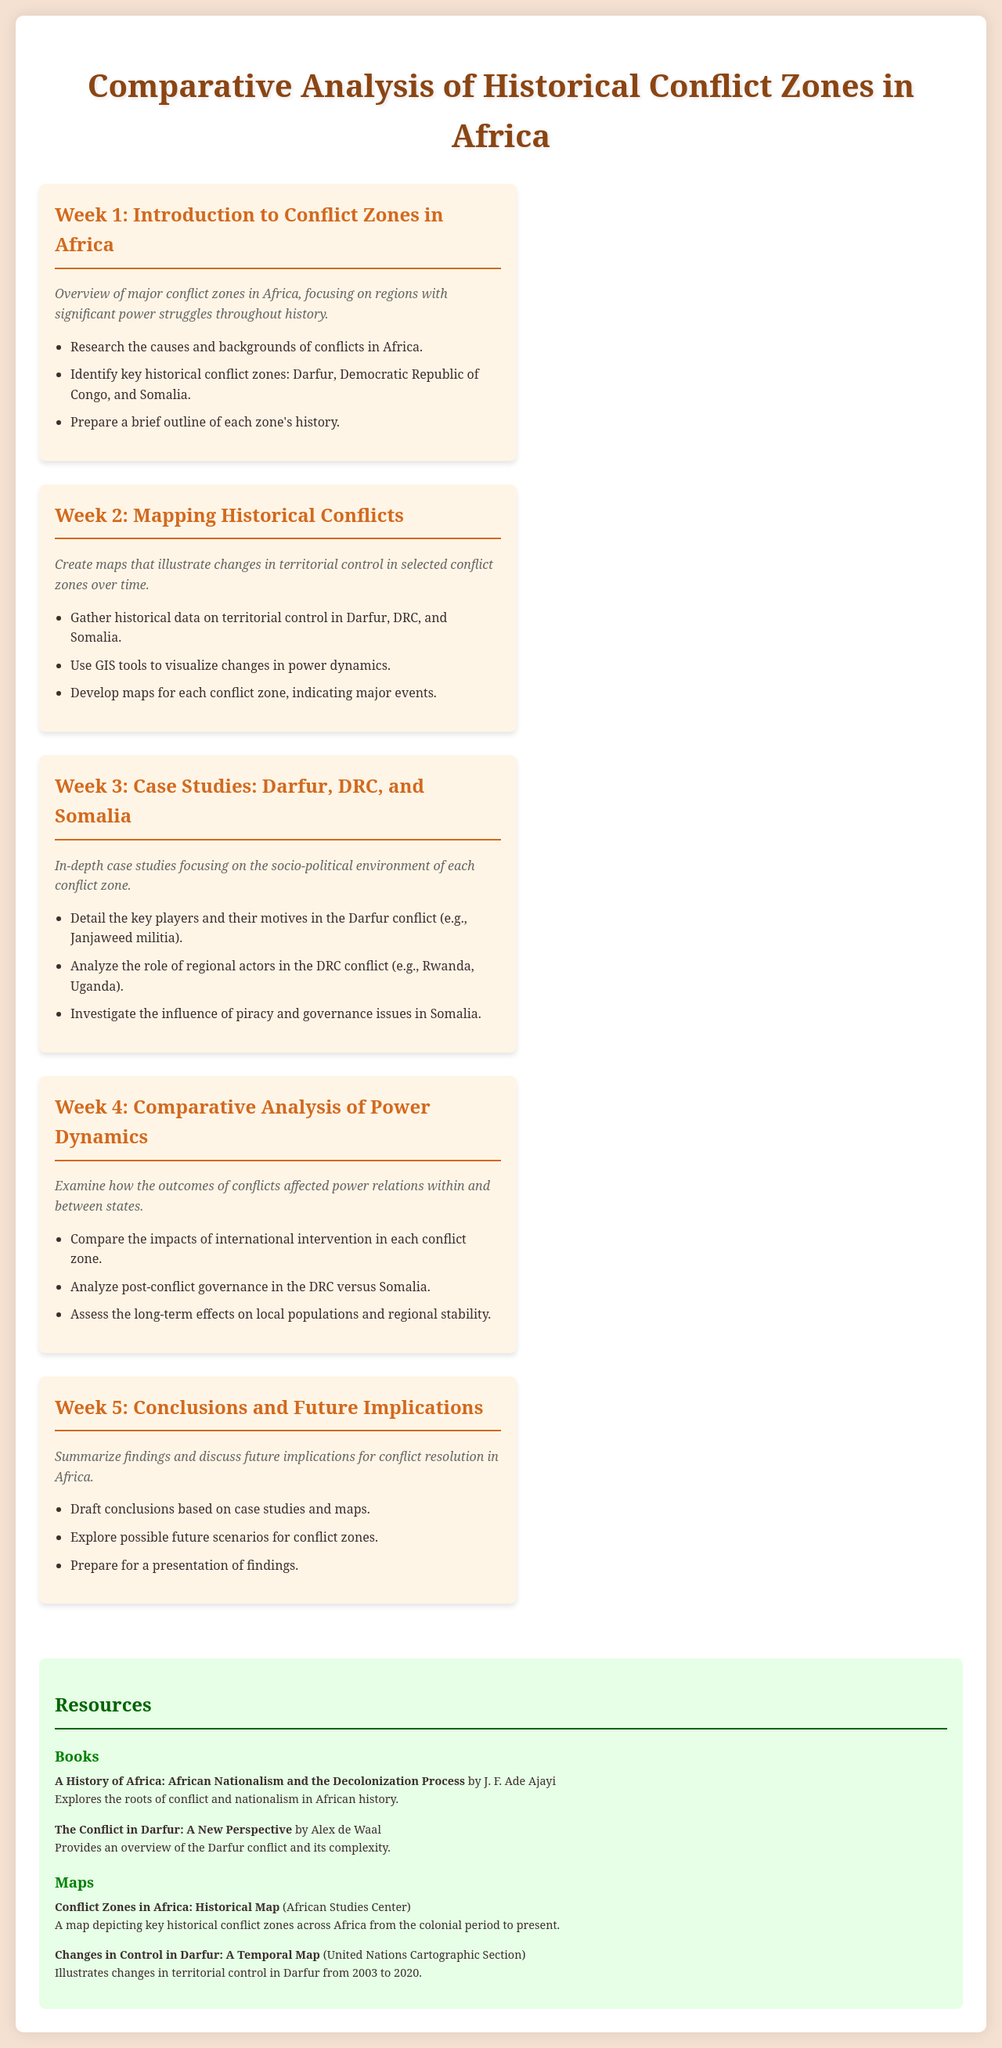What is the title of the document? The title of the document is provided in the header section of the HTML as "Comparative Analysis of Historical Conflict Zones in Africa."
Answer: Comparative Analysis of Historical Conflict Zones in Africa How many weeks does the schedule cover? The document lists five distinct weeks of content, outlining different focus areas for each week.
Answer: 5 Which major conflict zones are identified in Week 1? Week 1 outlines key historical conflict zones as Darfur, Democratic Republic of Congo, and Somalia.
Answer: Darfur, Democratic Republic of Congo, Somalia What type of tools are suggested for mapping in Week 2? Week 2 discusses the use of GIS tools for visualizing changes in power dynamics across the conflict zones.
Answer: GIS tools Which actor's role is analyzed in the DRC conflict during Week 3? Week 3 mentions analyzing the role of regional actors like Rwanda and Uganda in the DRC conflict.
Answer: Rwanda, Uganda What is the focus of Week 4's analysis? The document indicates that Week 4 focuses on comparing the impacts of international intervention in each conflict zone.
Answer: International intervention What is the main objective in Week 5? Week 5 aims to summarize findings and discuss future implications for conflict resolution in Africa based on earlier studies.
Answer: Conclusions and future implications What color scheme is used for the background of the document? The color scheme for the background is specified as a soft hue (#f4e1d2) in the styling provided.
Answer: #f4e1d2 What type of resources are listed at the end of the document? The document provides various resources such as books and maps related to the conflicts being analyzed.
Answer: Books and maps 